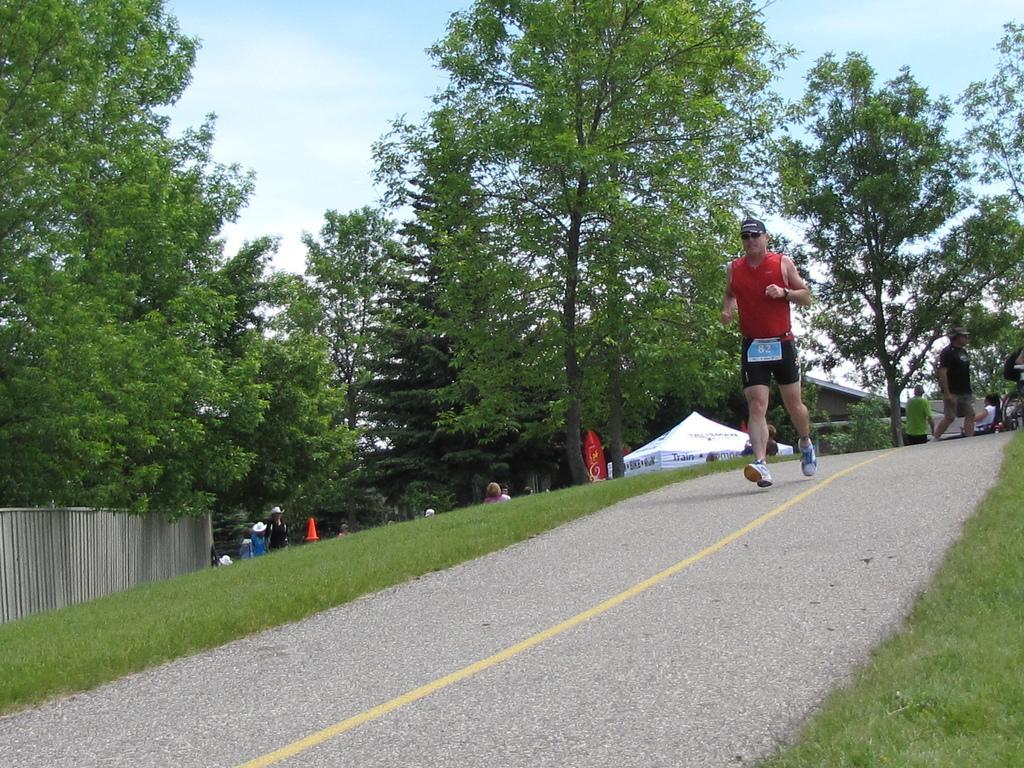Can you describe this image briefly? In this picture we can see a man is running on the path and on the left side of the man there is a wall. Behind the man there are some people, tent, building, trees and a sky. 